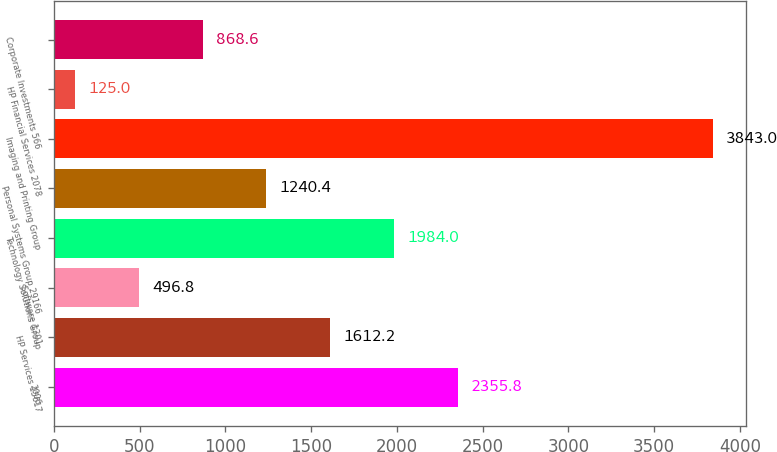Convert chart. <chart><loc_0><loc_0><loc_500><loc_500><bar_chart><fcel>2006<fcel>HP Services 15617<fcel>Software 1301<fcel>Technology Solutions Group<fcel>Personal Systems Group 29166<fcel>Imaging and Printing Group<fcel>HP Financial Services 2078<fcel>Corporate Investments 566<nl><fcel>2355.8<fcel>1612.2<fcel>496.8<fcel>1984<fcel>1240.4<fcel>3843<fcel>125<fcel>868.6<nl></chart> 